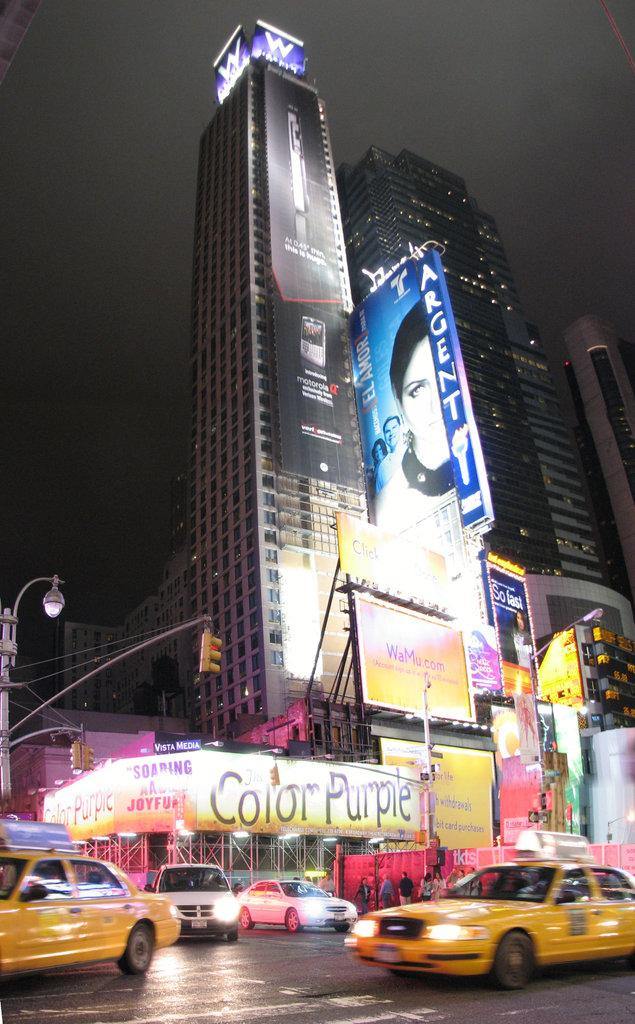Provide a one-sentence caption for the provided image. A busy city intersection near a sign for the Color Purple. 